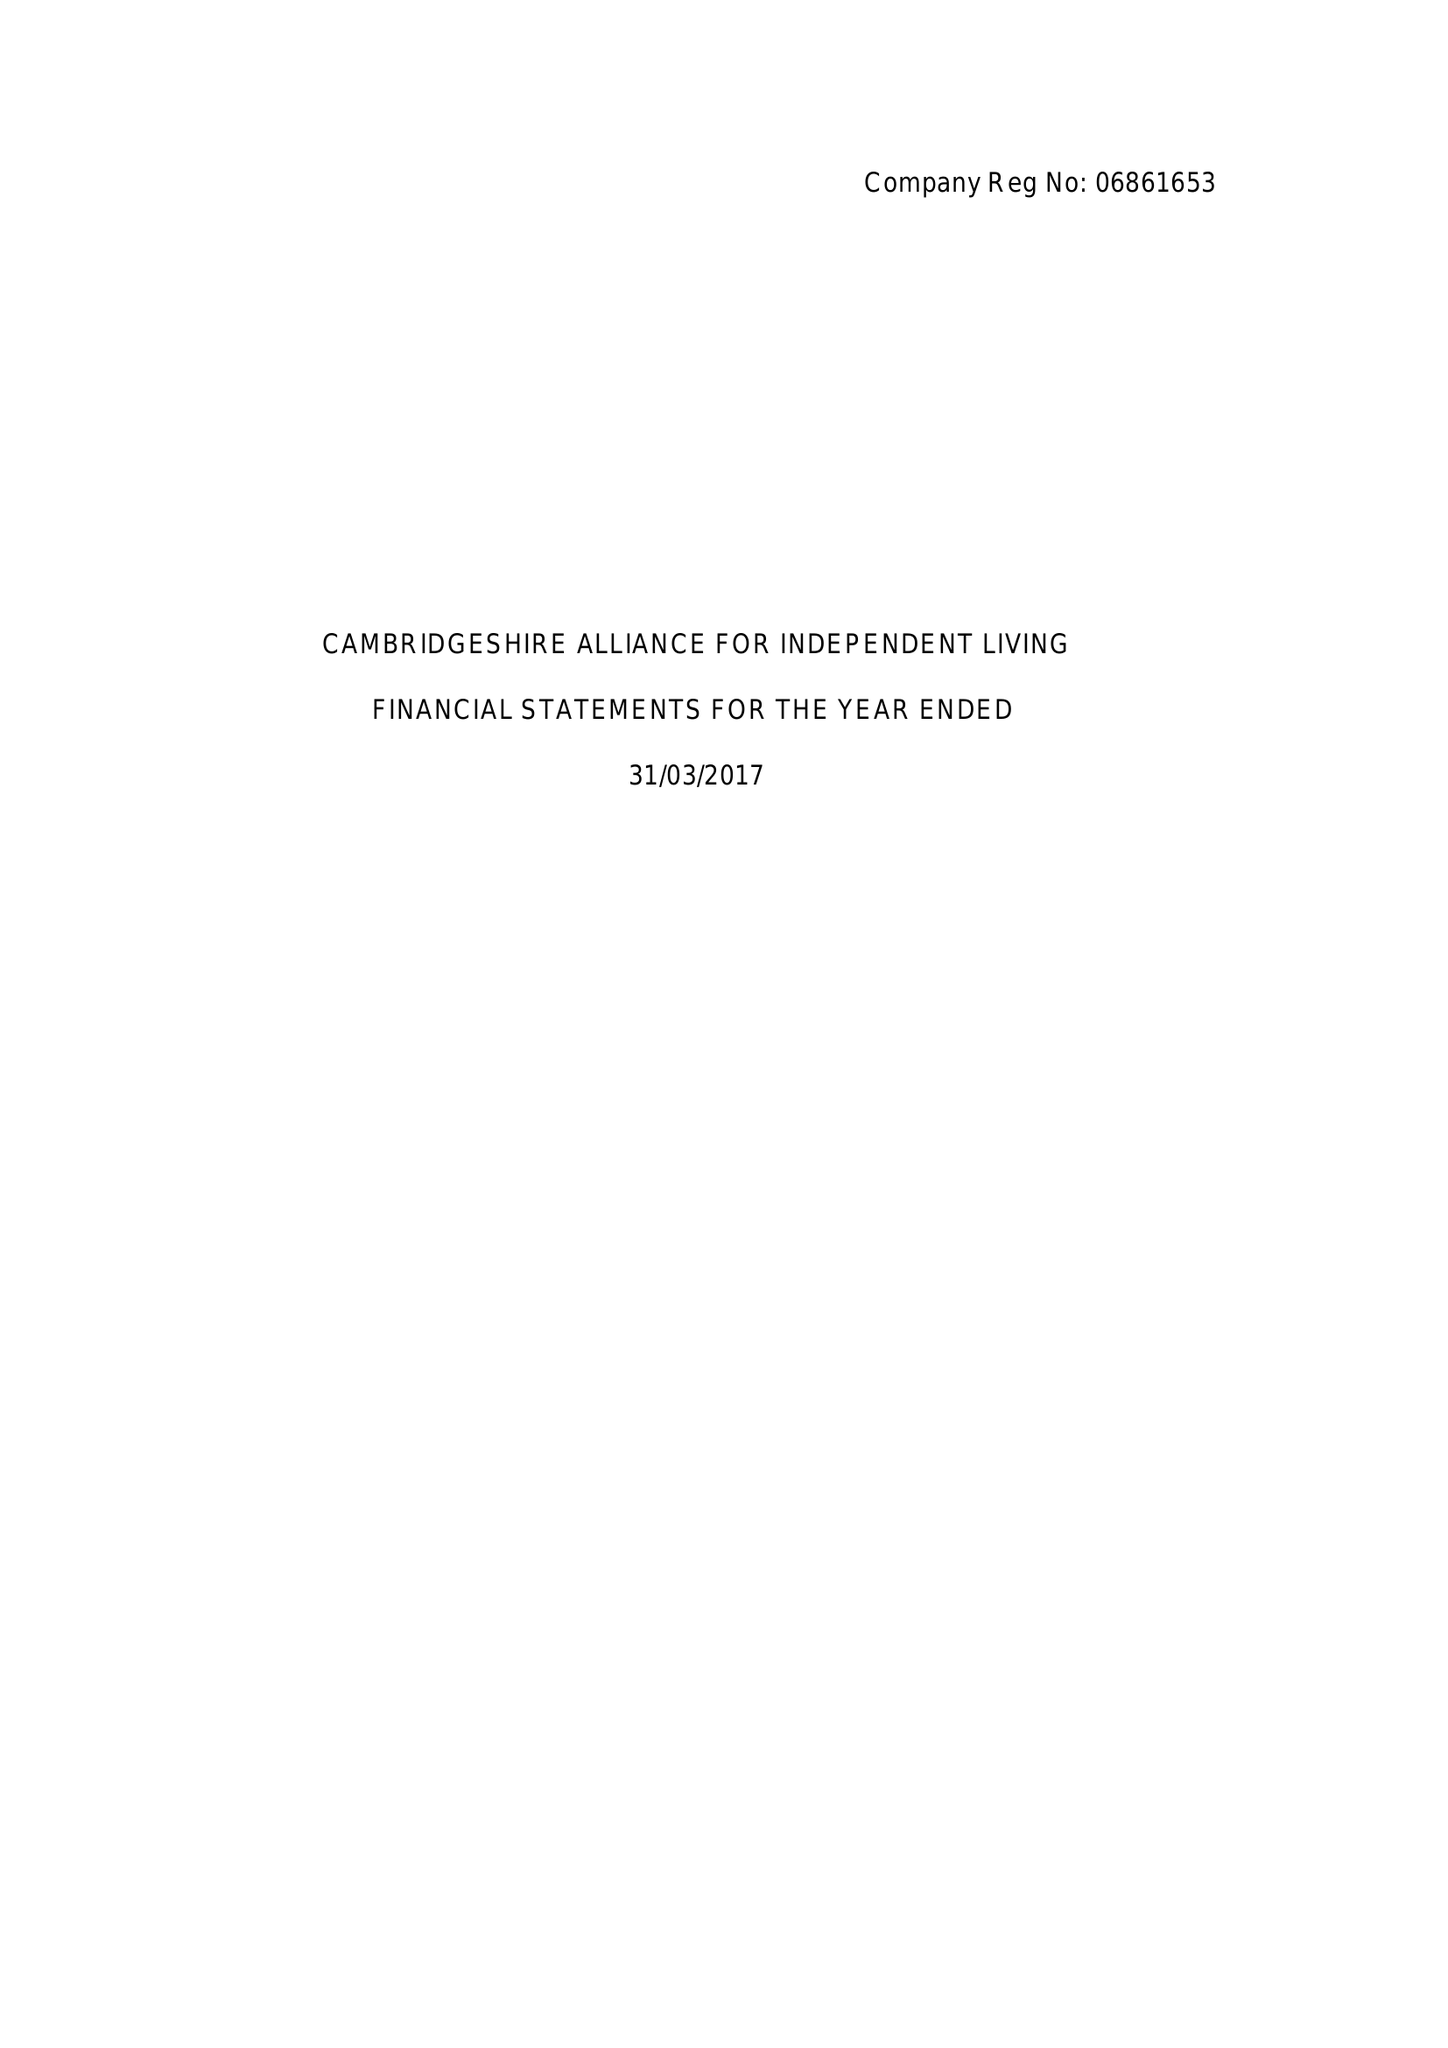What is the value for the address__post_town?
Answer the question using a single word or phrase. CAMBRIDGE 